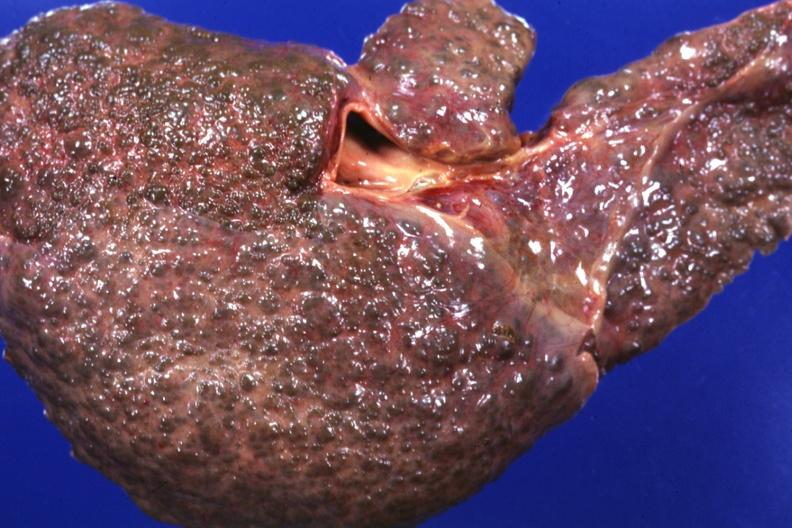s liver present?
Answer the question using a single word or phrase. Yes 